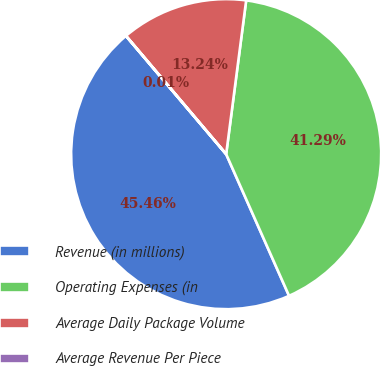Convert chart to OTSL. <chart><loc_0><loc_0><loc_500><loc_500><pie_chart><fcel>Revenue (in millions)<fcel>Operating Expenses (in<fcel>Average Daily Package Volume<fcel>Average Revenue Per Piece<nl><fcel>45.46%<fcel>41.29%<fcel>13.24%<fcel>0.01%<nl></chart> 